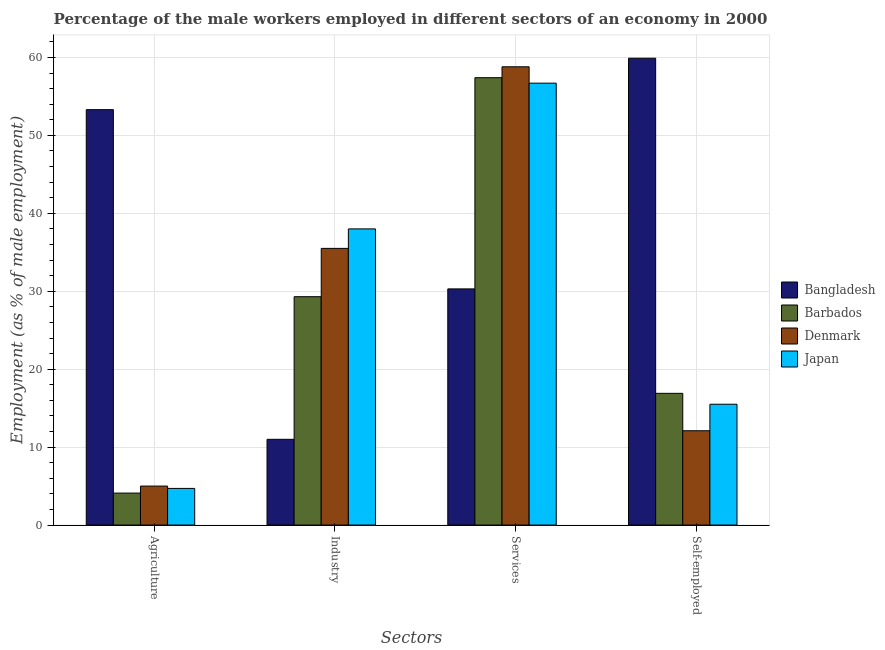How many different coloured bars are there?
Ensure brevity in your answer.  4. Are the number of bars per tick equal to the number of legend labels?
Your answer should be very brief. Yes. What is the label of the 1st group of bars from the left?
Your answer should be very brief. Agriculture. What is the percentage of self employed male workers in Bangladesh?
Offer a terse response. 59.9. Across all countries, what is the maximum percentage of self employed male workers?
Your response must be concise. 59.9. Across all countries, what is the minimum percentage of male workers in agriculture?
Ensure brevity in your answer.  4.1. In which country was the percentage of self employed male workers maximum?
Offer a very short reply. Bangladesh. What is the total percentage of male workers in services in the graph?
Ensure brevity in your answer.  203.2. What is the difference between the percentage of male workers in agriculture in Barbados and that in Japan?
Give a very brief answer. -0.6. What is the difference between the percentage of male workers in services in Denmark and the percentage of male workers in industry in Barbados?
Make the answer very short. 29.5. What is the average percentage of male workers in services per country?
Offer a very short reply. 50.8. What is the difference between the percentage of male workers in services and percentage of male workers in agriculture in Denmark?
Keep it short and to the point. 53.8. What is the ratio of the percentage of male workers in industry in Japan to that in Bangladesh?
Give a very brief answer. 3.45. Is the percentage of self employed male workers in Denmark less than that in Barbados?
Make the answer very short. Yes. What is the difference between the highest and the second highest percentage of male workers in agriculture?
Your answer should be compact. 48.3. What is the difference between the highest and the lowest percentage of male workers in services?
Ensure brevity in your answer.  28.5. Is the sum of the percentage of self employed male workers in Denmark and Barbados greater than the maximum percentage of male workers in services across all countries?
Ensure brevity in your answer.  No. Is it the case that in every country, the sum of the percentage of male workers in agriculture and percentage of male workers in industry is greater than the percentage of male workers in services?
Ensure brevity in your answer.  No. How many bars are there?
Offer a terse response. 16. Are all the bars in the graph horizontal?
Make the answer very short. No. Does the graph contain any zero values?
Give a very brief answer. No. How many legend labels are there?
Your answer should be very brief. 4. What is the title of the graph?
Provide a succinct answer. Percentage of the male workers employed in different sectors of an economy in 2000. Does "Sao Tome and Principe" appear as one of the legend labels in the graph?
Ensure brevity in your answer.  No. What is the label or title of the X-axis?
Offer a very short reply. Sectors. What is the label or title of the Y-axis?
Give a very brief answer. Employment (as % of male employment). What is the Employment (as % of male employment) in Bangladesh in Agriculture?
Provide a short and direct response. 53.3. What is the Employment (as % of male employment) of Barbados in Agriculture?
Provide a succinct answer. 4.1. What is the Employment (as % of male employment) of Denmark in Agriculture?
Provide a short and direct response. 5. What is the Employment (as % of male employment) of Japan in Agriculture?
Give a very brief answer. 4.7. What is the Employment (as % of male employment) of Barbados in Industry?
Your response must be concise. 29.3. What is the Employment (as % of male employment) of Denmark in Industry?
Provide a succinct answer. 35.5. What is the Employment (as % of male employment) in Japan in Industry?
Your answer should be very brief. 38. What is the Employment (as % of male employment) in Bangladesh in Services?
Ensure brevity in your answer.  30.3. What is the Employment (as % of male employment) of Barbados in Services?
Offer a very short reply. 57.4. What is the Employment (as % of male employment) in Denmark in Services?
Make the answer very short. 58.8. What is the Employment (as % of male employment) in Japan in Services?
Give a very brief answer. 56.7. What is the Employment (as % of male employment) in Bangladesh in Self-employed?
Your response must be concise. 59.9. What is the Employment (as % of male employment) of Barbados in Self-employed?
Provide a succinct answer. 16.9. What is the Employment (as % of male employment) of Denmark in Self-employed?
Provide a short and direct response. 12.1. Across all Sectors, what is the maximum Employment (as % of male employment) in Bangladesh?
Keep it short and to the point. 59.9. Across all Sectors, what is the maximum Employment (as % of male employment) in Barbados?
Your response must be concise. 57.4. Across all Sectors, what is the maximum Employment (as % of male employment) in Denmark?
Provide a succinct answer. 58.8. Across all Sectors, what is the maximum Employment (as % of male employment) in Japan?
Your answer should be compact. 56.7. Across all Sectors, what is the minimum Employment (as % of male employment) in Bangladesh?
Offer a very short reply. 11. Across all Sectors, what is the minimum Employment (as % of male employment) in Barbados?
Your answer should be very brief. 4.1. Across all Sectors, what is the minimum Employment (as % of male employment) in Japan?
Offer a very short reply. 4.7. What is the total Employment (as % of male employment) in Bangladesh in the graph?
Offer a terse response. 154.5. What is the total Employment (as % of male employment) in Barbados in the graph?
Keep it short and to the point. 107.7. What is the total Employment (as % of male employment) in Denmark in the graph?
Ensure brevity in your answer.  111.4. What is the total Employment (as % of male employment) in Japan in the graph?
Provide a succinct answer. 114.9. What is the difference between the Employment (as % of male employment) in Bangladesh in Agriculture and that in Industry?
Your answer should be very brief. 42.3. What is the difference between the Employment (as % of male employment) of Barbados in Agriculture and that in Industry?
Keep it short and to the point. -25.2. What is the difference between the Employment (as % of male employment) in Denmark in Agriculture and that in Industry?
Your response must be concise. -30.5. What is the difference between the Employment (as % of male employment) of Japan in Agriculture and that in Industry?
Provide a short and direct response. -33.3. What is the difference between the Employment (as % of male employment) of Bangladesh in Agriculture and that in Services?
Provide a short and direct response. 23. What is the difference between the Employment (as % of male employment) in Barbados in Agriculture and that in Services?
Ensure brevity in your answer.  -53.3. What is the difference between the Employment (as % of male employment) in Denmark in Agriculture and that in Services?
Your response must be concise. -53.8. What is the difference between the Employment (as % of male employment) in Japan in Agriculture and that in Services?
Your answer should be very brief. -52. What is the difference between the Employment (as % of male employment) in Barbados in Agriculture and that in Self-employed?
Your answer should be very brief. -12.8. What is the difference between the Employment (as % of male employment) of Japan in Agriculture and that in Self-employed?
Provide a succinct answer. -10.8. What is the difference between the Employment (as % of male employment) of Bangladesh in Industry and that in Services?
Your response must be concise. -19.3. What is the difference between the Employment (as % of male employment) in Barbados in Industry and that in Services?
Provide a succinct answer. -28.1. What is the difference between the Employment (as % of male employment) in Denmark in Industry and that in Services?
Provide a short and direct response. -23.3. What is the difference between the Employment (as % of male employment) in Japan in Industry and that in Services?
Your answer should be compact. -18.7. What is the difference between the Employment (as % of male employment) of Bangladesh in Industry and that in Self-employed?
Your answer should be compact. -48.9. What is the difference between the Employment (as % of male employment) in Barbados in Industry and that in Self-employed?
Provide a succinct answer. 12.4. What is the difference between the Employment (as % of male employment) of Denmark in Industry and that in Self-employed?
Provide a short and direct response. 23.4. What is the difference between the Employment (as % of male employment) of Japan in Industry and that in Self-employed?
Give a very brief answer. 22.5. What is the difference between the Employment (as % of male employment) of Bangladesh in Services and that in Self-employed?
Ensure brevity in your answer.  -29.6. What is the difference between the Employment (as % of male employment) in Barbados in Services and that in Self-employed?
Offer a very short reply. 40.5. What is the difference between the Employment (as % of male employment) in Denmark in Services and that in Self-employed?
Offer a terse response. 46.7. What is the difference between the Employment (as % of male employment) of Japan in Services and that in Self-employed?
Your response must be concise. 41.2. What is the difference between the Employment (as % of male employment) of Bangladesh in Agriculture and the Employment (as % of male employment) of Barbados in Industry?
Your answer should be compact. 24. What is the difference between the Employment (as % of male employment) of Bangladesh in Agriculture and the Employment (as % of male employment) of Denmark in Industry?
Provide a succinct answer. 17.8. What is the difference between the Employment (as % of male employment) of Barbados in Agriculture and the Employment (as % of male employment) of Denmark in Industry?
Your response must be concise. -31.4. What is the difference between the Employment (as % of male employment) of Barbados in Agriculture and the Employment (as % of male employment) of Japan in Industry?
Ensure brevity in your answer.  -33.9. What is the difference between the Employment (as % of male employment) in Denmark in Agriculture and the Employment (as % of male employment) in Japan in Industry?
Ensure brevity in your answer.  -33. What is the difference between the Employment (as % of male employment) in Bangladesh in Agriculture and the Employment (as % of male employment) in Denmark in Services?
Your answer should be compact. -5.5. What is the difference between the Employment (as % of male employment) in Barbados in Agriculture and the Employment (as % of male employment) in Denmark in Services?
Offer a terse response. -54.7. What is the difference between the Employment (as % of male employment) of Barbados in Agriculture and the Employment (as % of male employment) of Japan in Services?
Your answer should be very brief. -52.6. What is the difference between the Employment (as % of male employment) of Denmark in Agriculture and the Employment (as % of male employment) of Japan in Services?
Keep it short and to the point. -51.7. What is the difference between the Employment (as % of male employment) of Bangladesh in Agriculture and the Employment (as % of male employment) of Barbados in Self-employed?
Make the answer very short. 36.4. What is the difference between the Employment (as % of male employment) in Bangladesh in Agriculture and the Employment (as % of male employment) in Denmark in Self-employed?
Offer a terse response. 41.2. What is the difference between the Employment (as % of male employment) of Bangladesh in Agriculture and the Employment (as % of male employment) of Japan in Self-employed?
Offer a terse response. 37.8. What is the difference between the Employment (as % of male employment) in Barbados in Agriculture and the Employment (as % of male employment) in Japan in Self-employed?
Make the answer very short. -11.4. What is the difference between the Employment (as % of male employment) of Denmark in Agriculture and the Employment (as % of male employment) of Japan in Self-employed?
Provide a succinct answer. -10.5. What is the difference between the Employment (as % of male employment) in Bangladesh in Industry and the Employment (as % of male employment) in Barbados in Services?
Your answer should be very brief. -46.4. What is the difference between the Employment (as % of male employment) in Bangladesh in Industry and the Employment (as % of male employment) in Denmark in Services?
Give a very brief answer. -47.8. What is the difference between the Employment (as % of male employment) in Bangladesh in Industry and the Employment (as % of male employment) in Japan in Services?
Provide a short and direct response. -45.7. What is the difference between the Employment (as % of male employment) of Barbados in Industry and the Employment (as % of male employment) of Denmark in Services?
Provide a short and direct response. -29.5. What is the difference between the Employment (as % of male employment) of Barbados in Industry and the Employment (as % of male employment) of Japan in Services?
Keep it short and to the point. -27.4. What is the difference between the Employment (as % of male employment) in Denmark in Industry and the Employment (as % of male employment) in Japan in Services?
Provide a short and direct response. -21.2. What is the difference between the Employment (as % of male employment) in Bangladesh in Industry and the Employment (as % of male employment) in Barbados in Self-employed?
Offer a terse response. -5.9. What is the difference between the Employment (as % of male employment) in Barbados in Industry and the Employment (as % of male employment) in Denmark in Self-employed?
Provide a short and direct response. 17.2. What is the difference between the Employment (as % of male employment) in Bangladesh in Services and the Employment (as % of male employment) in Barbados in Self-employed?
Keep it short and to the point. 13.4. What is the difference between the Employment (as % of male employment) of Bangladesh in Services and the Employment (as % of male employment) of Japan in Self-employed?
Your response must be concise. 14.8. What is the difference between the Employment (as % of male employment) in Barbados in Services and the Employment (as % of male employment) in Denmark in Self-employed?
Your answer should be compact. 45.3. What is the difference between the Employment (as % of male employment) of Barbados in Services and the Employment (as % of male employment) of Japan in Self-employed?
Your response must be concise. 41.9. What is the difference between the Employment (as % of male employment) in Denmark in Services and the Employment (as % of male employment) in Japan in Self-employed?
Provide a short and direct response. 43.3. What is the average Employment (as % of male employment) in Bangladesh per Sectors?
Make the answer very short. 38.62. What is the average Employment (as % of male employment) in Barbados per Sectors?
Give a very brief answer. 26.93. What is the average Employment (as % of male employment) of Denmark per Sectors?
Your response must be concise. 27.85. What is the average Employment (as % of male employment) of Japan per Sectors?
Your response must be concise. 28.73. What is the difference between the Employment (as % of male employment) of Bangladesh and Employment (as % of male employment) of Barbados in Agriculture?
Offer a terse response. 49.2. What is the difference between the Employment (as % of male employment) in Bangladesh and Employment (as % of male employment) in Denmark in Agriculture?
Provide a short and direct response. 48.3. What is the difference between the Employment (as % of male employment) of Bangladesh and Employment (as % of male employment) of Japan in Agriculture?
Your response must be concise. 48.6. What is the difference between the Employment (as % of male employment) in Barbados and Employment (as % of male employment) in Japan in Agriculture?
Provide a succinct answer. -0.6. What is the difference between the Employment (as % of male employment) of Denmark and Employment (as % of male employment) of Japan in Agriculture?
Ensure brevity in your answer.  0.3. What is the difference between the Employment (as % of male employment) in Bangladesh and Employment (as % of male employment) in Barbados in Industry?
Keep it short and to the point. -18.3. What is the difference between the Employment (as % of male employment) of Bangladesh and Employment (as % of male employment) of Denmark in Industry?
Offer a terse response. -24.5. What is the difference between the Employment (as % of male employment) in Barbados and Employment (as % of male employment) in Denmark in Industry?
Make the answer very short. -6.2. What is the difference between the Employment (as % of male employment) of Barbados and Employment (as % of male employment) of Japan in Industry?
Your response must be concise. -8.7. What is the difference between the Employment (as % of male employment) in Bangladesh and Employment (as % of male employment) in Barbados in Services?
Provide a short and direct response. -27.1. What is the difference between the Employment (as % of male employment) in Bangladesh and Employment (as % of male employment) in Denmark in Services?
Your response must be concise. -28.5. What is the difference between the Employment (as % of male employment) in Bangladesh and Employment (as % of male employment) in Japan in Services?
Provide a short and direct response. -26.4. What is the difference between the Employment (as % of male employment) of Bangladesh and Employment (as % of male employment) of Denmark in Self-employed?
Your answer should be very brief. 47.8. What is the difference between the Employment (as % of male employment) in Bangladesh and Employment (as % of male employment) in Japan in Self-employed?
Provide a succinct answer. 44.4. What is the difference between the Employment (as % of male employment) in Barbados and Employment (as % of male employment) in Denmark in Self-employed?
Your response must be concise. 4.8. What is the difference between the Employment (as % of male employment) of Barbados and Employment (as % of male employment) of Japan in Self-employed?
Ensure brevity in your answer.  1.4. What is the ratio of the Employment (as % of male employment) of Bangladesh in Agriculture to that in Industry?
Your response must be concise. 4.85. What is the ratio of the Employment (as % of male employment) in Barbados in Agriculture to that in Industry?
Offer a very short reply. 0.14. What is the ratio of the Employment (as % of male employment) in Denmark in Agriculture to that in Industry?
Provide a short and direct response. 0.14. What is the ratio of the Employment (as % of male employment) in Japan in Agriculture to that in Industry?
Offer a very short reply. 0.12. What is the ratio of the Employment (as % of male employment) of Bangladesh in Agriculture to that in Services?
Ensure brevity in your answer.  1.76. What is the ratio of the Employment (as % of male employment) of Barbados in Agriculture to that in Services?
Your answer should be very brief. 0.07. What is the ratio of the Employment (as % of male employment) in Denmark in Agriculture to that in Services?
Offer a terse response. 0.09. What is the ratio of the Employment (as % of male employment) of Japan in Agriculture to that in Services?
Your answer should be compact. 0.08. What is the ratio of the Employment (as % of male employment) in Bangladesh in Agriculture to that in Self-employed?
Your answer should be compact. 0.89. What is the ratio of the Employment (as % of male employment) of Barbados in Agriculture to that in Self-employed?
Your answer should be very brief. 0.24. What is the ratio of the Employment (as % of male employment) in Denmark in Agriculture to that in Self-employed?
Offer a terse response. 0.41. What is the ratio of the Employment (as % of male employment) of Japan in Agriculture to that in Self-employed?
Ensure brevity in your answer.  0.3. What is the ratio of the Employment (as % of male employment) of Bangladesh in Industry to that in Services?
Make the answer very short. 0.36. What is the ratio of the Employment (as % of male employment) in Barbados in Industry to that in Services?
Keep it short and to the point. 0.51. What is the ratio of the Employment (as % of male employment) of Denmark in Industry to that in Services?
Provide a succinct answer. 0.6. What is the ratio of the Employment (as % of male employment) in Japan in Industry to that in Services?
Give a very brief answer. 0.67. What is the ratio of the Employment (as % of male employment) in Bangladesh in Industry to that in Self-employed?
Give a very brief answer. 0.18. What is the ratio of the Employment (as % of male employment) in Barbados in Industry to that in Self-employed?
Provide a succinct answer. 1.73. What is the ratio of the Employment (as % of male employment) in Denmark in Industry to that in Self-employed?
Provide a short and direct response. 2.93. What is the ratio of the Employment (as % of male employment) of Japan in Industry to that in Self-employed?
Provide a short and direct response. 2.45. What is the ratio of the Employment (as % of male employment) of Bangladesh in Services to that in Self-employed?
Your answer should be very brief. 0.51. What is the ratio of the Employment (as % of male employment) of Barbados in Services to that in Self-employed?
Ensure brevity in your answer.  3.4. What is the ratio of the Employment (as % of male employment) of Denmark in Services to that in Self-employed?
Give a very brief answer. 4.86. What is the ratio of the Employment (as % of male employment) of Japan in Services to that in Self-employed?
Your answer should be very brief. 3.66. What is the difference between the highest and the second highest Employment (as % of male employment) in Bangladesh?
Your answer should be compact. 6.6. What is the difference between the highest and the second highest Employment (as % of male employment) in Barbados?
Make the answer very short. 28.1. What is the difference between the highest and the second highest Employment (as % of male employment) of Denmark?
Your answer should be compact. 23.3. What is the difference between the highest and the lowest Employment (as % of male employment) in Bangladesh?
Make the answer very short. 48.9. What is the difference between the highest and the lowest Employment (as % of male employment) of Barbados?
Make the answer very short. 53.3. What is the difference between the highest and the lowest Employment (as % of male employment) of Denmark?
Your answer should be very brief. 53.8. 